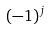Convert formula to latex. <formula><loc_0><loc_0><loc_500><loc_500>( - 1 ) ^ { j }</formula> 